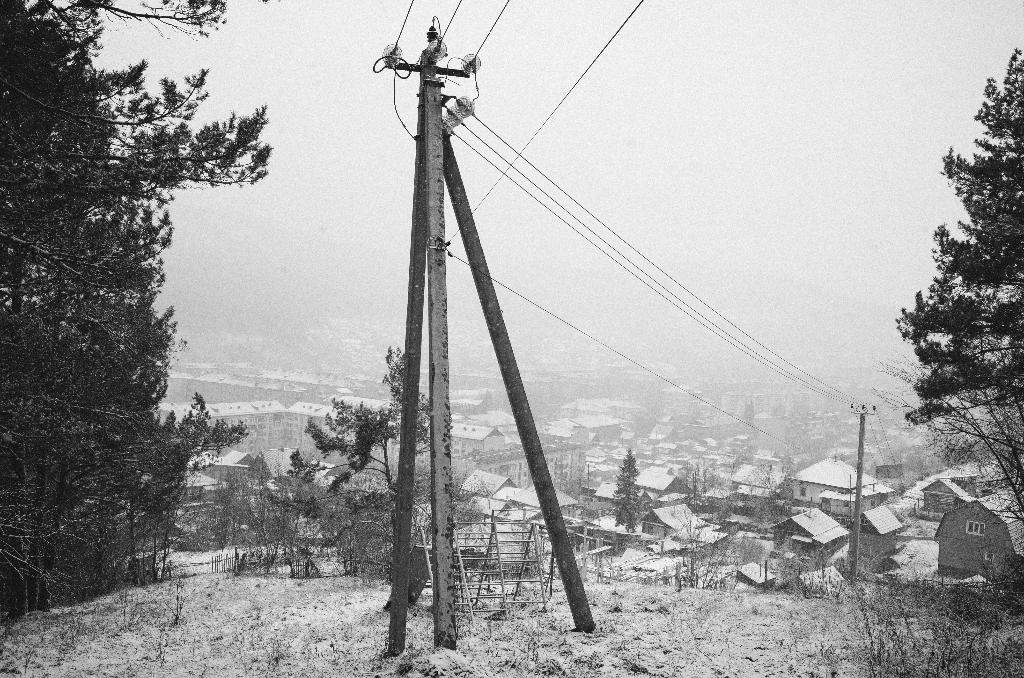What type of structures can be seen in the image? There are houses in the image. What other objects can be seen in the image besides houses? There are electric poles and trees visible in the image. What is the weather condition in the image? There is snow visible in the image. What time of day is it in the image, and how many hours have passed? The image does not provide information about the time of day or the number of hours that have passed. Can you tell me how many times the trees have been copied in the image? The trees in the image are not copies; they are real trees. 